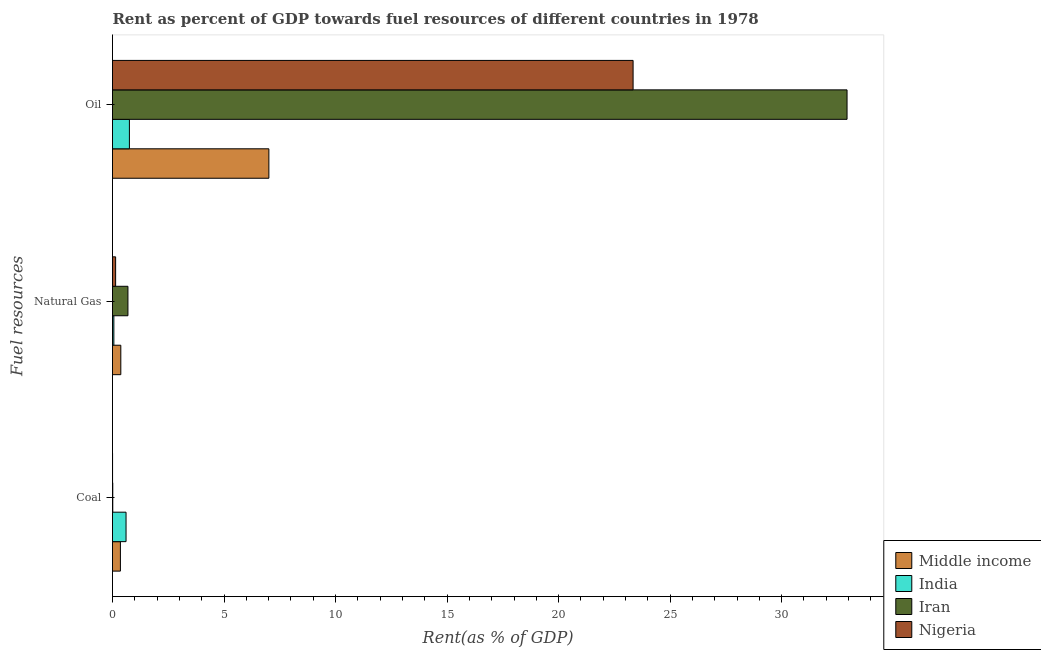How many different coloured bars are there?
Offer a terse response. 4. How many bars are there on the 1st tick from the top?
Make the answer very short. 4. How many bars are there on the 3rd tick from the bottom?
Offer a very short reply. 4. What is the label of the 2nd group of bars from the top?
Provide a succinct answer. Natural Gas. What is the rent towards oil in India?
Your answer should be very brief. 0.76. Across all countries, what is the maximum rent towards oil?
Your answer should be very brief. 32.93. Across all countries, what is the minimum rent towards natural gas?
Make the answer very short. 0.06. In which country was the rent towards oil maximum?
Give a very brief answer. Iran. In which country was the rent towards coal minimum?
Provide a succinct answer. Nigeria. What is the total rent towards coal in the graph?
Offer a very short reply. 0.98. What is the difference between the rent towards natural gas in Middle income and that in Iran?
Offer a terse response. -0.32. What is the difference between the rent towards oil in Iran and the rent towards coal in Nigeria?
Make the answer very short. 32.93. What is the average rent towards coal per country?
Ensure brevity in your answer.  0.24. What is the difference between the rent towards coal and rent towards oil in India?
Offer a very short reply. -0.15. What is the ratio of the rent towards oil in Middle income to that in Nigeria?
Offer a very short reply. 0.3. Is the rent towards coal in Iran less than that in Nigeria?
Keep it short and to the point. No. What is the difference between the highest and the second highest rent towards oil?
Provide a succinct answer. 9.59. What is the difference between the highest and the lowest rent towards oil?
Your answer should be compact. 32.17. What does the 3rd bar from the top in Natural Gas represents?
Your response must be concise. India. What does the 1st bar from the bottom in Coal represents?
Offer a very short reply. Middle income. How many bars are there?
Your answer should be compact. 12. Are all the bars in the graph horizontal?
Provide a short and direct response. Yes. How many countries are there in the graph?
Provide a succinct answer. 4. Does the graph contain any zero values?
Keep it short and to the point. No. Does the graph contain grids?
Your answer should be compact. No. How many legend labels are there?
Provide a short and direct response. 4. How are the legend labels stacked?
Provide a short and direct response. Vertical. What is the title of the graph?
Keep it short and to the point. Rent as percent of GDP towards fuel resources of different countries in 1978. What is the label or title of the X-axis?
Ensure brevity in your answer.  Rent(as % of GDP). What is the label or title of the Y-axis?
Keep it short and to the point. Fuel resources. What is the Rent(as % of GDP) of Middle income in Coal?
Offer a terse response. 0.35. What is the Rent(as % of GDP) of India in Coal?
Give a very brief answer. 0.61. What is the Rent(as % of GDP) of Iran in Coal?
Provide a short and direct response. 0.01. What is the Rent(as % of GDP) in Nigeria in Coal?
Give a very brief answer. 0. What is the Rent(as % of GDP) of Middle income in Natural Gas?
Your answer should be compact. 0.37. What is the Rent(as % of GDP) in India in Natural Gas?
Provide a short and direct response. 0.06. What is the Rent(as % of GDP) in Iran in Natural Gas?
Your answer should be compact. 0.69. What is the Rent(as % of GDP) in Nigeria in Natural Gas?
Keep it short and to the point. 0.14. What is the Rent(as % of GDP) of Middle income in Oil?
Provide a succinct answer. 7.01. What is the Rent(as % of GDP) in India in Oil?
Give a very brief answer. 0.76. What is the Rent(as % of GDP) in Iran in Oil?
Provide a succinct answer. 32.93. What is the Rent(as % of GDP) in Nigeria in Oil?
Offer a very short reply. 23.34. Across all Fuel resources, what is the maximum Rent(as % of GDP) of Middle income?
Keep it short and to the point. 7.01. Across all Fuel resources, what is the maximum Rent(as % of GDP) of India?
Make the answer very short. 0.76. Across all Fuel resources, what is the maximum Rent(as % of GDP) in Iran?
Provide a short and direct response. 32.93. Across all Fuel resources, what is the maximum Rent(as % of GDP) in Nigeria?
Your answer should be very brief. 23.34. Across all Fuel resources, what is the minimum Rent(as % of GDP) of Middle income?
Offer a terse response. 0.35. Across all Fuel resources, what is the minimum Rent(as % of GDP) of India?
Ensure brevity in your answer.  0.06. Across all Fuel resources, what is the minimum Rent(as % of GDP) in Iran?
Your response must be concise. 0.01. Across all Fuel resources, what is the minimum Rent(as % of GDP) in Nigeria?
Provide a succinct answer. 0. What is the total Rent(as % of GDP) in Middle income in the graph?
Your response must be concise. 7.74. What is the total Rent(as % of GDP) in India in the graph?
Provide a succinct answer. 1.43. What is the total Rent(as % of GDP) in Iran in the graph?
Your response must be concise. 33.64. What is the total Rent(as % of GDP) in Nigeria in the graph?
Offer a very short reply. 23.48. What is the difference between the Rent(as % of GDP) in Middle income in Coal and that in Natural Gas?
Provide a short and direct response. -0.02. What is the difference between the Rent(as % of GDP) in India in Coal and that in Natural Gas?
Provide a short and direct response. 0.55. What is the difference between the Rent(as % of GDP) of Iran in Coal and that in Natural Gas?
Keep it short and to the point. -0.68. What is the difference between the Rent(as % of GDP) of Nigeria in Coal and that in Natural Gas?
Give a very brief answer. -0.14. What is the difference between the Rent(as % of GDP) in Middle income in Coal and that in Oil?
Offer a very short reply. -6.66. What is the difference between the Rent(as % of GDP) of India in Coal and that in Oil?
Offer a very short reply. -0.15. What is the difference between the Rent(as % of GDP) of Iran in Coal and that in Oil?
Your answer should be very brief. -32.92. What is the difference between the Rent(as % of GDP) in Nigeria in Coal and that in Oil?
Provide a succinct answer. -23.34. What is the difference between the Rent(as % of GDP) in Middle income in Natural Gas and that in Oil?
Offer a terse response. -6.64. What is the difference between the Rent(as % of GDP) of India in Natural Gas and that in Oil?
Provide a succinct answer. -0.7. What is the difference between the Rent(as % of GDP) in Iran in Natural Gas and that in Oil?
Your answer should be compact. -32.24. What is the difference between the Rent(as % of GDP) of Nigeria in Natural Gas and that in Oil?
Offer a terse response. -23.2. What is the difference between the Rent(as % of GDP) in Middle income in Coal and the Rent(as % of GDP) in India in Natural Gas?
Offer a terse response. 0.29. What is the difference between the Rent(as % of GDP) in Middle income in Coal and the Rent(as % of GDP) in Iran in Natural Gas?
Ensure brevity in your answer.  -0.34. What is the difference between the Rent(as % of GDP) of Middle income in Coal and the Rent(as % of GDP) of Nigeria in Natural Gas?
Your response must be concise. 0.21. What is the difference between the Rent(as % of GDP) of India in Coal and the Rent(as % of GDP) of Iran in Natural Gas?
Make the answer very short. -0.08. What is the difference between the Rent(as % of GDP) in India in Coal and the Rent(as % of GDP) in Nigeria in Natural Gas?
Offer a very short reply. 0.47. What is the difference between the Rent(as % of GDP) in Iran in Coal and the Rent(as % of GDP) in Nigeria in Natural Gas?
Your answer should be compact. -0.13. What is the difference between the Rent(as % of GDP) in Middle income in Coal and the Rent(as % of GDP) in India in Oil?
Offer a terse response. -0.4. What is the difference between the Rent(as % of GDP) in Middle income in Coal and the Rent(as % of GDP) in Iran in Oil?
Provide a succinct answer. -32.58. What is the difference between the Rent(as % of GDP) of Middle income in Coal and the Rent(as % of GDP) of Nigeria in Oil?
Make the answer very short. -22.99. What is the difference between the Rent(as % of GDP) in India in Coal and the Rent(as % of GDP) in Iran in Oil?
Offer a terse response. -32.32. What is the difference between the Rent(as % of GDP) in India in Coal and the Rent(as % of GDP) in Nigeria in Oil?
Your answer should be very brief. -22.73. What is the difference between the Rent(as % of GDP) in Iran in Coal and the Rent(as % of GDP) in Nigeria in Oil?
Make the answer very short. -23.33. What is the difference between the Rent(as % of GDP) of Middle income in Natural Gas and the Rent(as % of GDP) of India in Oil?
Ensure brevity in your answer.  -0.39. What is the difference between the Rent(as % of GDP) in Middle income in Natural Gas and the Rent(as % of GDP) in Iran in Oil?
Make the answer very short. -32.56. What is the difference between the Rent(as % of GDP) in Middle income in Natural Gas and the Rent(as % of GDP) in Nigeria in Oil?
Your answer should be compact. -22.97. What is the difference between the Rent(as % of GDP) of India in Natural Gas and the Rent(as % of GDP) of Iran in Oil?
Ensure brevity in your answer.  -32.87. What is the difference between the Rent(as % of GDP) of India in Natural Gas and the Rent(as % of GDP) of Nigeria in Oil?
Give a very brief answer. -23.28. What is the difference between the Rent(as % of GDP) in Iran in Natural Gas and the Rent(as % of GDP) in Nigeria in Oil?
Your response must be concise. -22.65. What is the average Rent(as % of GDP) in Middle income per Fuel resources?
Offer a terse response. 2.58. What is the average Rent(as % of GDP) in India per Fuel resources?
Make the answer very short. 0.48. What is the average Rent(as % of GDP) of Iran per Fuel resources?
Your response must be concise. 11.21. What is the average Rent(as % of GDP) of Nigeria per Fuel resources?
Give a very brief answer. 7.83. What is the difference between the Rent(as % of GDP) of Middle income and Rent(as % of GDP) of India in Coal?
Keep it short and to the point. -0.25. What is the difference between the Rent(as % of GDP) of Middle income and Rent(as % of GDP) of Iran in Coal?
Keep it short and to the point. 0.34. What is the difference between the Rent(as % of GDP) of Middle income and Rent(as % of GDP) of Nigeria in Coal?
Give a very brief answer. 0.35. What is the difference between the Rent(as % of GDP) of India and Rent(as % of GDP) of Iran in Coal?
Your response must be concise. 0.59. What is the difference between the Rent(as % of GDP) in India and Rent(as % of GDP) in Nigeria in Coal?
Provide a succinct answer. 0.6. What is the difference between the Rent(as % of GDP) in Iran and Rent(as % of GDP) in Nigeria in Coal?
Make the answer very short. 0.01. What is the difference between the Rent(as % of GDP) of Middle income and Rent(as % of GDP) of India in Natural Gas?
Keep it short and to the point. 0.31. What is the difference between the Rent(as % of GDP) of Middle income and Rent(as % of GDP) of Iran in Natural Gas?
Make the answer very short. -0.32. What is the difference between the Rent(as % of GDP) of Middle income and Rent(as % of GDP) of Nigeria in Natural Gas?
Provide a succinct answer. 0.23. What is the difference between the Rent(as % of GDP) in India and Rent(as % of GDP) in Iran in Natural Gas?
Offer a very short reply. -0.63. What is the difference between the Rent(as % of GDP) in India and Rent(as % of GDP) in Nigeria in Natural Gas?
Ensure brevity in your answer.  -0.08. What is the difference between the Rent(as % of GDP) in Iran and Rent(as % of GDP) in Nigeria in Natural Gas?
Provide a succinct answer. 0.55. What is the difference between the Rent(as % of GDP) in Middle income and Rent(as % of GDP) in India in Oil?
Provide a short and direct response. 6.25. What is the difference between the Rent(as % of GDP) of Middle income and Rent(as % of GDP) of Iran in Oil?
Offer a terse response. -25.92. What is the difference between the Rent(as % of GDP) of Middle income and Rent(as % of GDP) of Nigeria in Oil?
Offer a very short reply. -16.33. What is the difference between the Rent(as % of GDP) of India and Rent(as % of GDP) of Iran in Oil?
Offer a very short reply. -32.17. What is the difference between the Rent(as % of GDP) of India and Rent(as % of GDP) of Nigeria in Oil?
Offer a very short reply. -22.58. What is the difference between the Rent(as % of GDP) of Iran and Rent(as % of GDP) of Nigeria in Oil?
Provide a short and direct response. 9.59. What is the ratio of the Rent(as % of GDP) of Middle income in Coal to that in Natural Gas?
Make the answer very short. 0.95. What is the ratio of the Rent(as % of GDP) in India in Coal to that in Natural Gas?
Give a very brief answer. 10.03. What is the ratio of the Rent(as % of GDP) in Iran in Coal to that in Natural Gas?
Provide a short and direct response. 0.02. What is the ratio of the Rent(as % of GDP) in Nigeria in Coal to that in Natural Gas?
Your response must be concise. 0.02. What is the ratio of the Rent(as % of GDP) of Middle income in Coal to that in Oil?
Offer a very short reply. 0.05. What is the ratio of the Rent(as % of GDP) of India in Coal to that in Oil?
Provide a short and direct response. 0.8. What is the ratio of the Rent(as % of GDP) in Middle income in Natural Gas to that in Oil?
Offer a terse response. 0.05. What is the ratio of the Rent(as % of GDP) of India in Natural Gas to that in Oil?
Your response must be concise. 0.08. What is the ratio of the Rent(as % of GDP) of Iran in Natural Gas to that in Oil?
Provide a short and direct response. 0.02. What is the ratio of the Rent(as % of GDP) of Nigeria in Natural Gas to that in Oil?
Provide a short and direct response. 0.01. What is the difference between the highest and the second highest Rent(as % of GDP) in Middle income?
Provide a short and direct response. 6.64. What is the difference between the highest and the second highest Rent(as % of GDP) of India?
Offer a very short reply. 0.15. What is the difference between the highest and the second highest Rent(as % of GDP) in Iran?
Keep it short and to the point. 32.24. What is the difference between the highest and the second highest Rent(as % of GDP) in Nigeria?
Offer a terse response. 23.2. What is the difference between the highest and the lowest Rent(as % of GDP) of Middle income?
Provide a succinct answer. 6.66. What is the difference between the highest and the lowest Rent(as % of GDP) of India?
Make the answer very short. 0.7. What is the difference between the highest and the lowest Rent(as % of GDP) in Iran?
Your answer should be very brief. 32.92. What is the difference between the highest and the lowest Rent(as % of GDP) in Nigeria?
Keep it short and to the point. 23.34. 